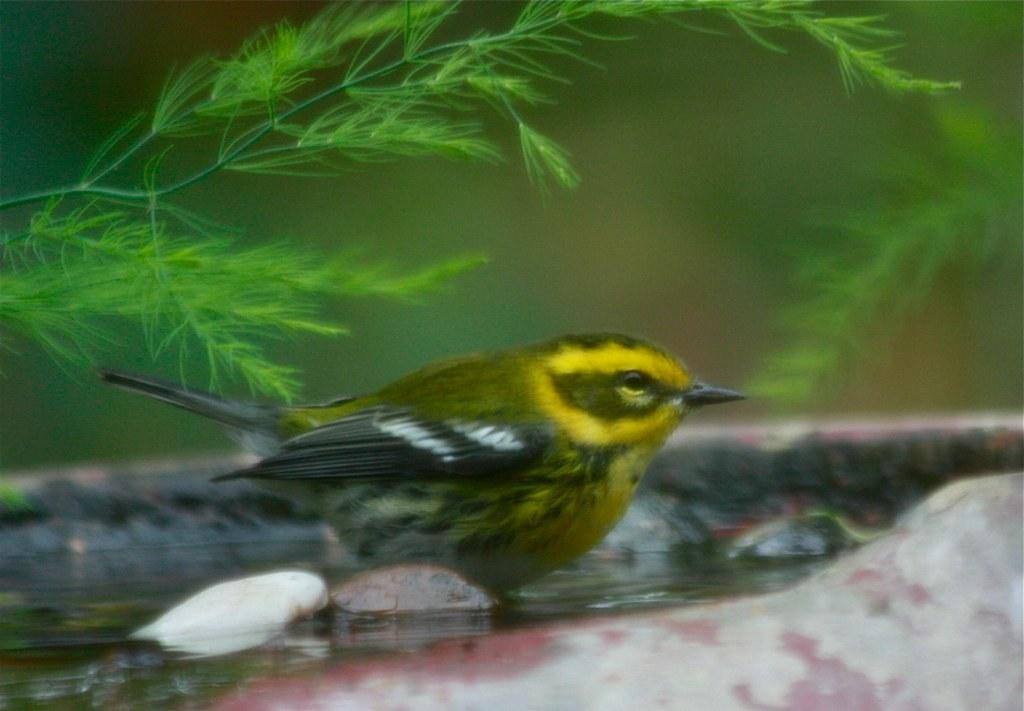What is located in the water in the foreground of the image? There is a bird in the water in the foreground of the image. What can be seen at the bottom of the water? There appears to be stone at the bottom of the water. What type of vegetation or plants can be seen at the top of the image? Greenery is visible at the top of the image. What type of hose is being used to water the plants in the image? There is no hose present in the image; it features a bird in the water with stone at the bottom and greenery at the top. 